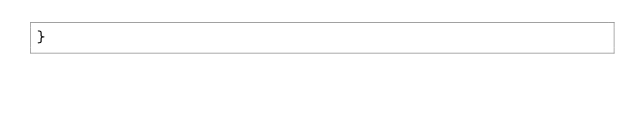Convert code to text. <code><loc_0><loc_0><loc_500><loc_500><_Scala_>}
</code> 